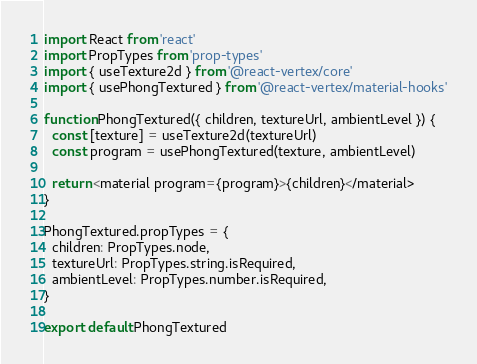<code> <loc_0><loc_0><loc_500><loc_500><_JavaScript_>import React from 'react'
import PropTypes from 'prop-types'
import { useTexture2d } from '@react-vertex/core'
import { usePhongTextured } from '@react-vertex/material-hooks'

function PhongTextured({ children, textureUrl, ambientLevel }) {
  const [texture] = useTexture2d(textureUrl)
  const program = usePhongTextured(texture, ambientLevel)

  return <material program={program}>{children}</material>
}

PhongTextured.propTypes = {
  children: PropTypes.node,
  textureUrl: PropTypes.string.isRequired,
  ambientLevel: PropTypes.number.isRequired,
}

export default PhongTextured
</code> 